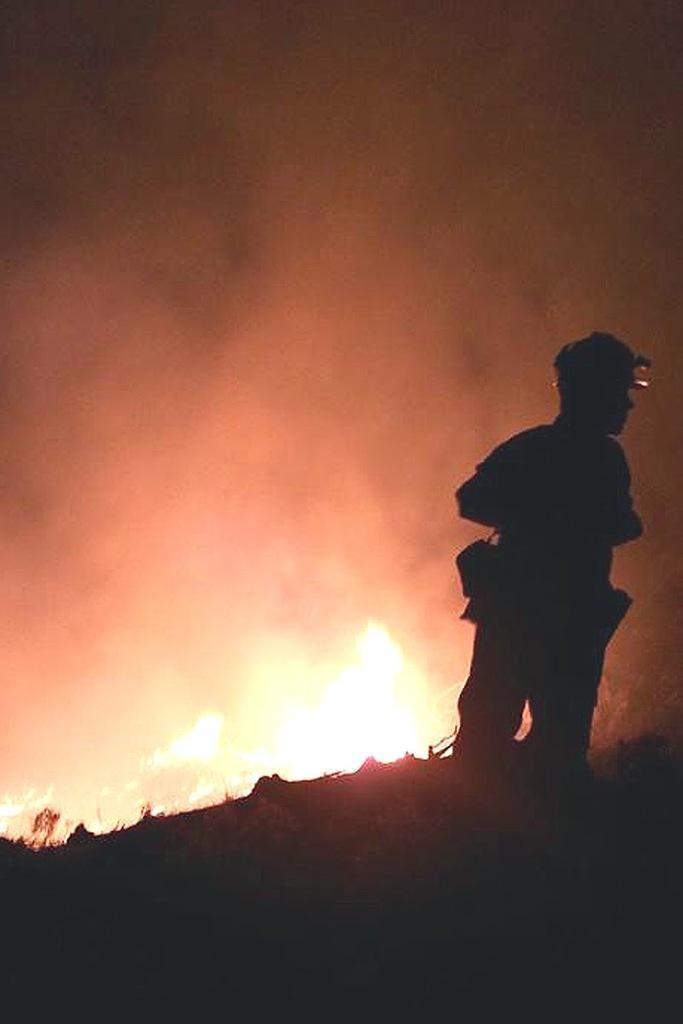In one or two sentences, can you explain what this image depicts? In the image we can see a person standing. There is flame and smoke. 